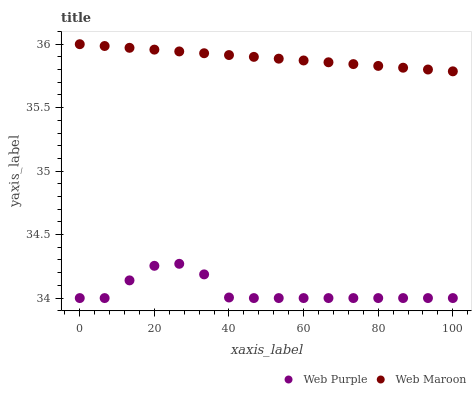Does Web Purple have the minimum area under the curve?
Answer yes or no. Yes. Does Web Maroon have the maximum area under the curve?
Answer yes or no. Yes. Does Web Maroon have the minimum area under the curve?
Answer yes or no. No. Is Web Maroon the smoothest?
Answer yes or no. Yes. Is Web Purple the roughest?
Answer yes or no. Yes. Is Web Maroon the roughest?
Answer yes or no. No. Does Web Purple have the lowest value?
Answer yes or no. Yes. Does Web Maroon have the lowest value?
Answer yes or no. No. Does Web Maroon have the highest value?
Answer yes or no. Yes. Is Web Purple less than Web Maroon?
Answer yes or no. Yes. Is Web Maroon greater than Web Purple?
Answer yes or no. Yes. Does Web Purple intersect Web Maroon?
Answer yes or no. No. 